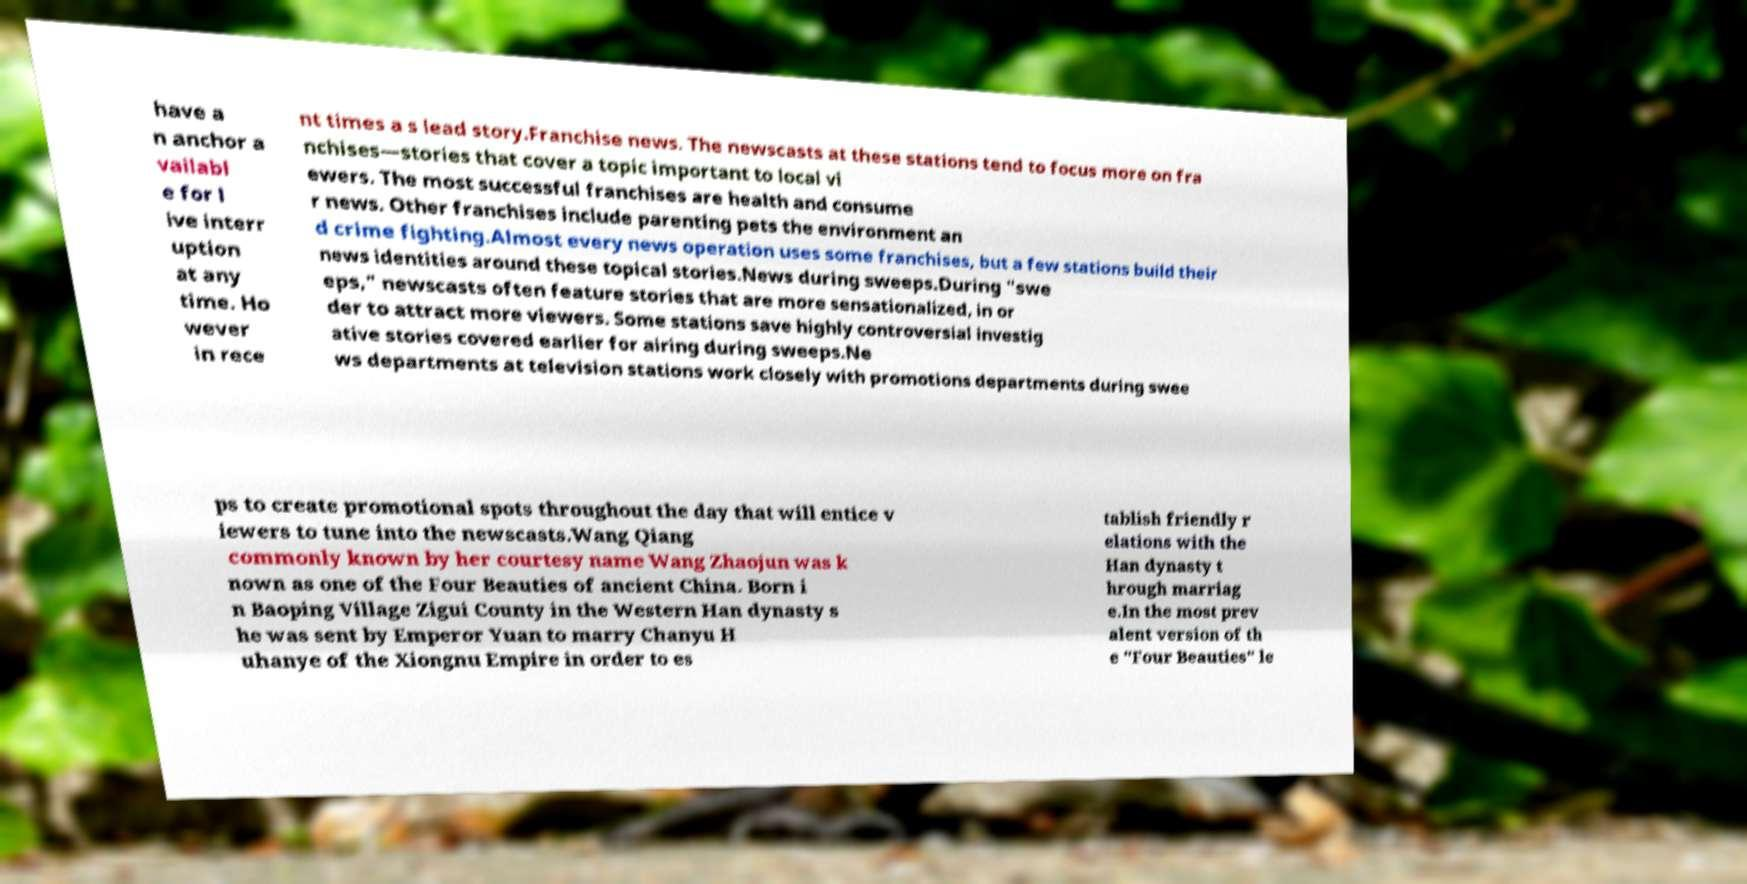Can you accurately transcribe the text from the provided image for me? have a n anchor a vailabl e for l ive interr uption at any time. Ho wever in rece nt times a s lead story.Franchise news. The newscasts at these stations tend to focus more on fra nchises—stories that cover a topic important to local vi ewers. The most successful franchises are health and consume r news. Other franchises include parenting pets the environment an d crime fighting.Almost every news operation uses some franchises, but a few stations build their news identities around these topical stories.News during sweeps.During "swe eps," newscasts often feature stories that are more sensationalized, in or der to attract more viewers. Some stations save highly controversial investig ative stories covered earlier for airing during sweeps.Ne ws departments at television stations work closely with promotions departments during swee ps to create promotional spots throughout the day that will entice v iewers to tune into the newscasts.Wang Qiang commonly known by her courtesy name Wang Zhaojun was k nown as one of the Four Beauties of ancient China. Born i n Baoping Village Zigui County in the Western Han dynasty s he was sent by Emperor Yuan to marry Chanyu H uhanye of the Xiongnu Empire in order to es tablish friendly r elations with the Han dynasty t hrough marriag e.In the most prev alent version of th e "Four Beauties" le 